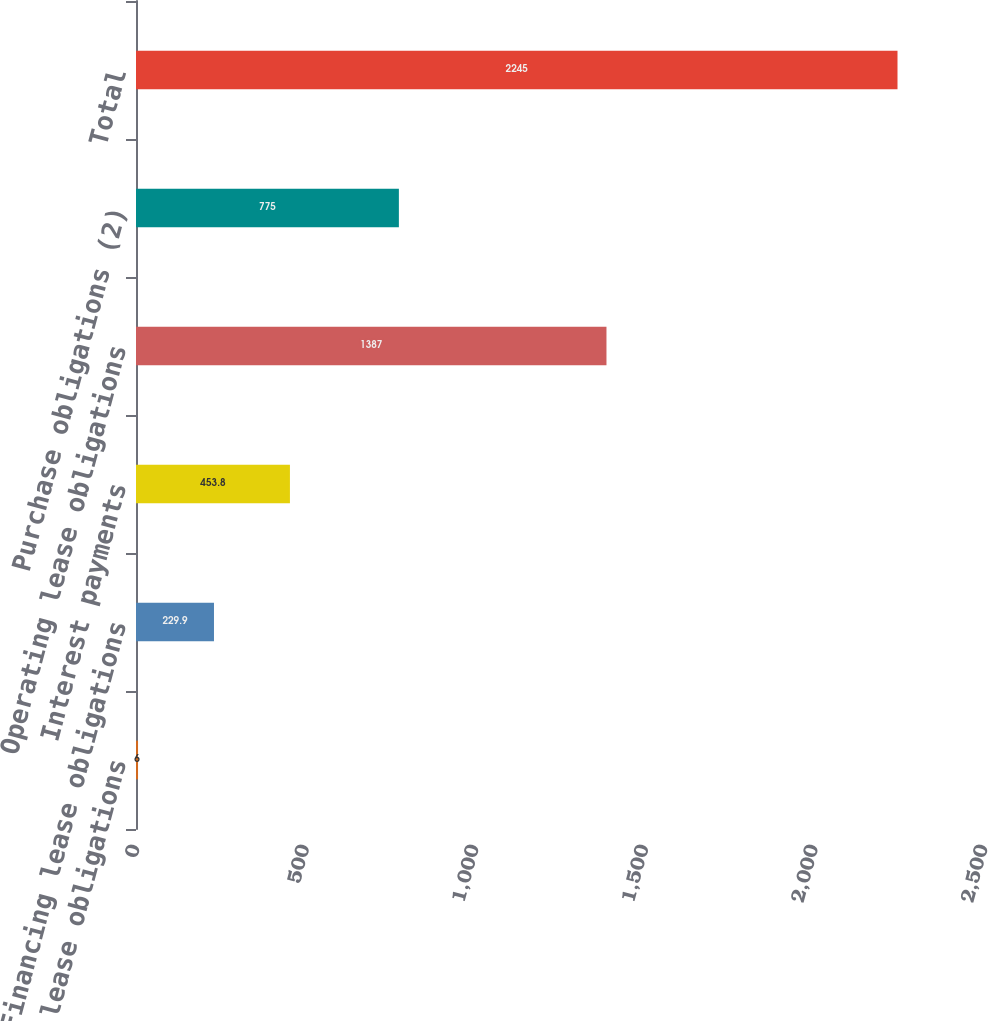Convert chart to OTSL. <chart><loc_0><loc_0><loc_500><loc_500><bar_chart><fcel>Capital lease obligations<fcel>Financing lease obligations<fcel>Interest payments<fcel>Operating lease obligations<fcel>Purchase obligations (2)<fcel>Total<nl><fcel>6<fcel>229.9<fcel>453.8<fcel>1387<fcel>775<fcel>2245<nl></chart> 